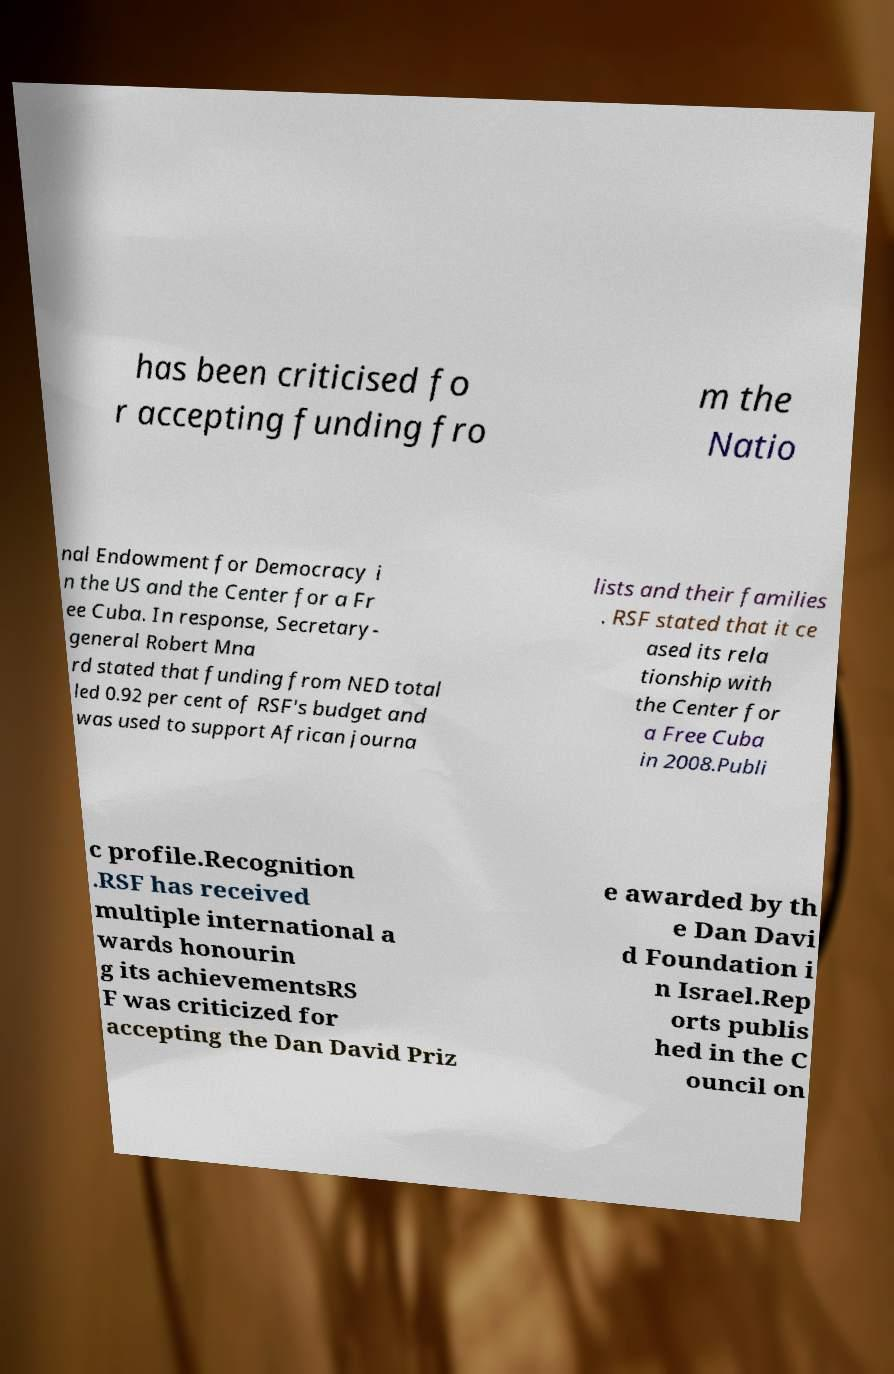What messages or text are displayed in this image? I need them in a readable, typed format. has been criticised fo r accepting funding fro m the Natio nal Endowment for Democracy i n the US and the Center for a Fr ee Cuba. In response, Secretary- general Robert Mna rd stated that funding from NED total led 0.92 per cent of RSF's budget and was used to support African journa lists and their families . RSF stated that it ce ased its rela tionship with the Center for a Free Cuba in 2008.Publi c profile.Recognition .RSF has received multiple international a wards honourin g its achievementsRS F was criticized for accepting the Dan David Priz e awarded by th e Dan Davi d Foundation i n Israel.Rep orts publis hed in the C ouncil on 